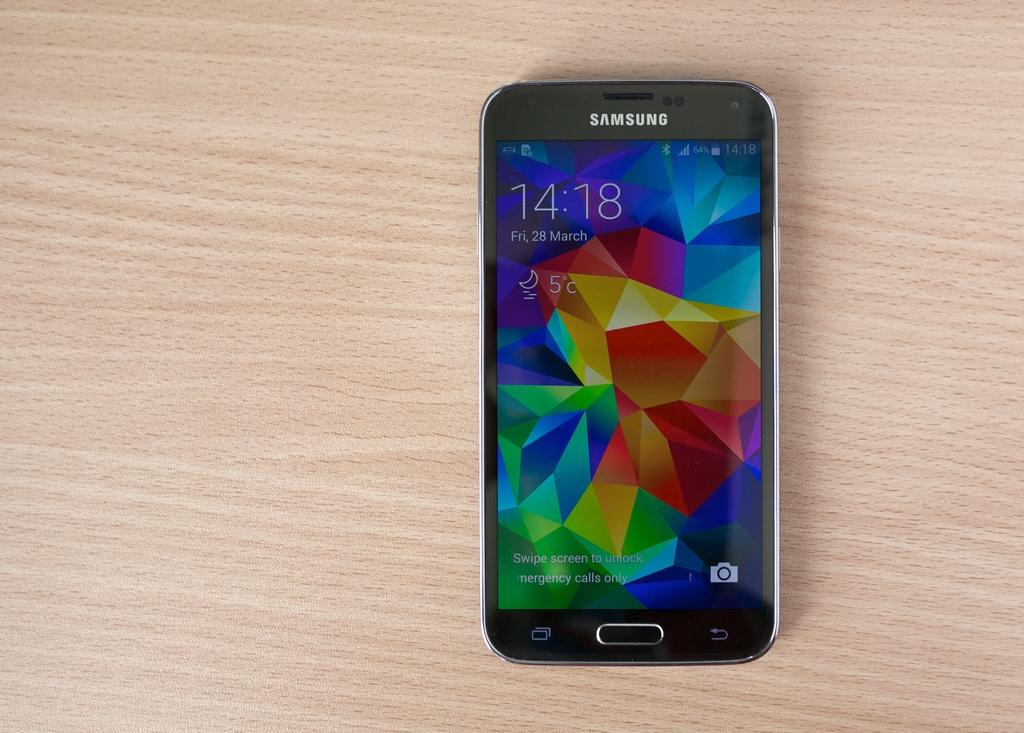What electronic device is visible in the image? There is a mobile phone in the image. What is the mobile phone placed on? The mobile phone is placed on a wooden surface. What type of lead can be seen connecting the mobile phone to the wall in the image? There is no lead connecting the mobile phone to the wall in the image; the mobile phone is simply placed on a wooden surface. 